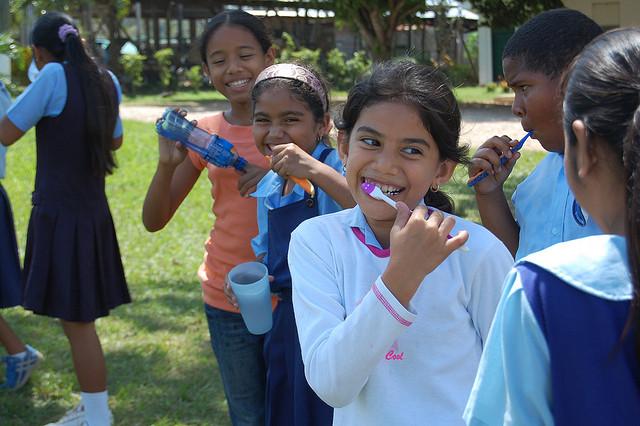Are the children happy?
Give a very brief answer. Yes. What are they doing to their teeth?
Keep it brief. Brushing. Are all the children wearing uniforms?
Quick response, please. No. 